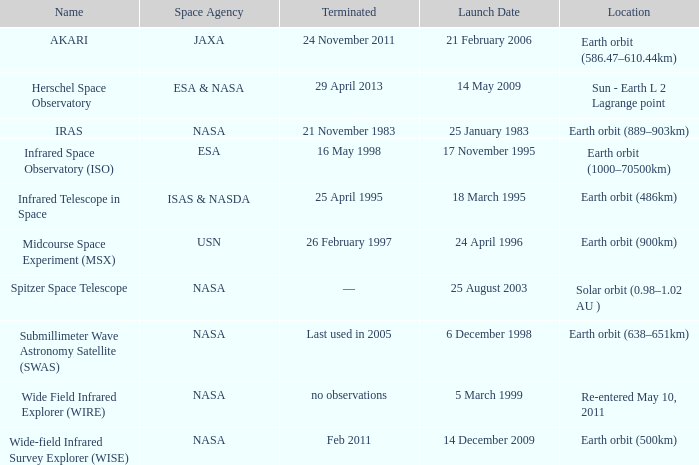When did NASA launch the wide field infrared explorer (wire)? 5 March 1999. 